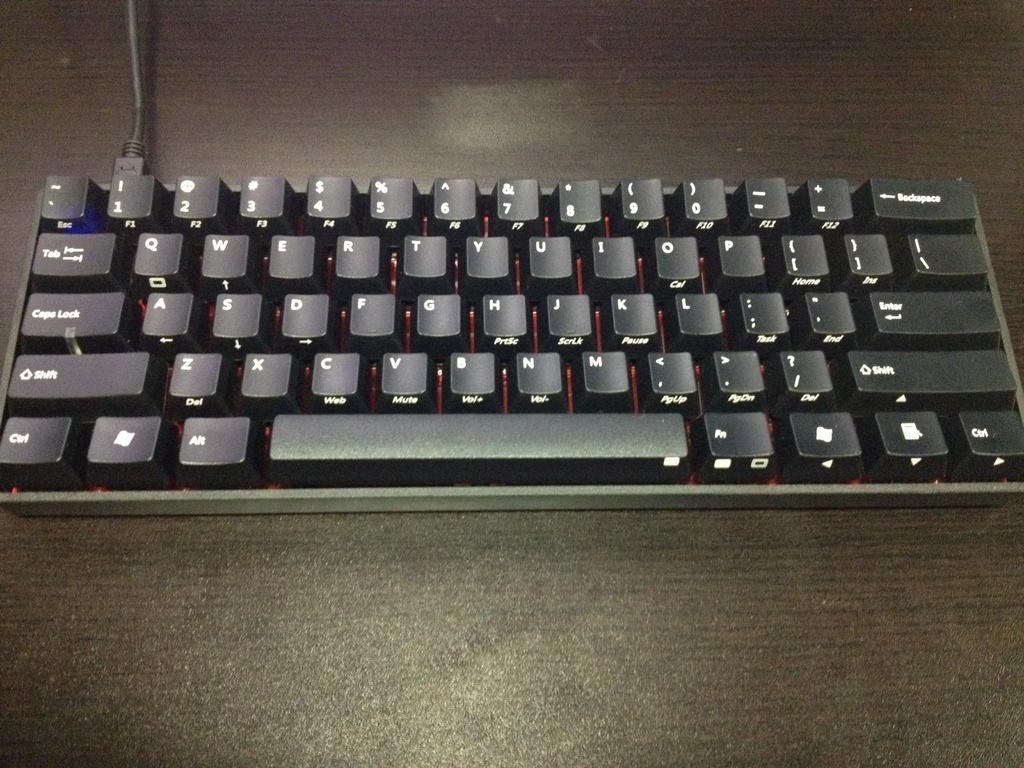Could you give a brief overview of what you see in this image? As we can see in the image there is a black color keyboard and a wire. 